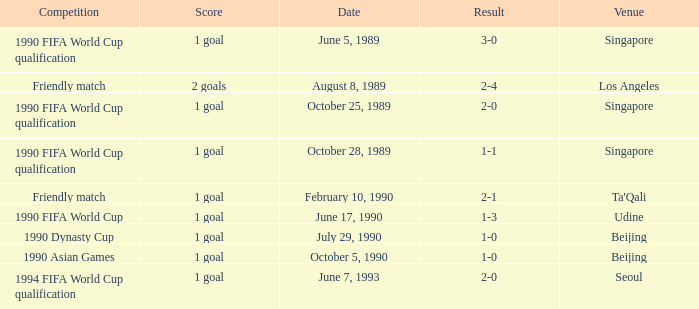What is the score of the match on October 5, 1990? 1 goal. 